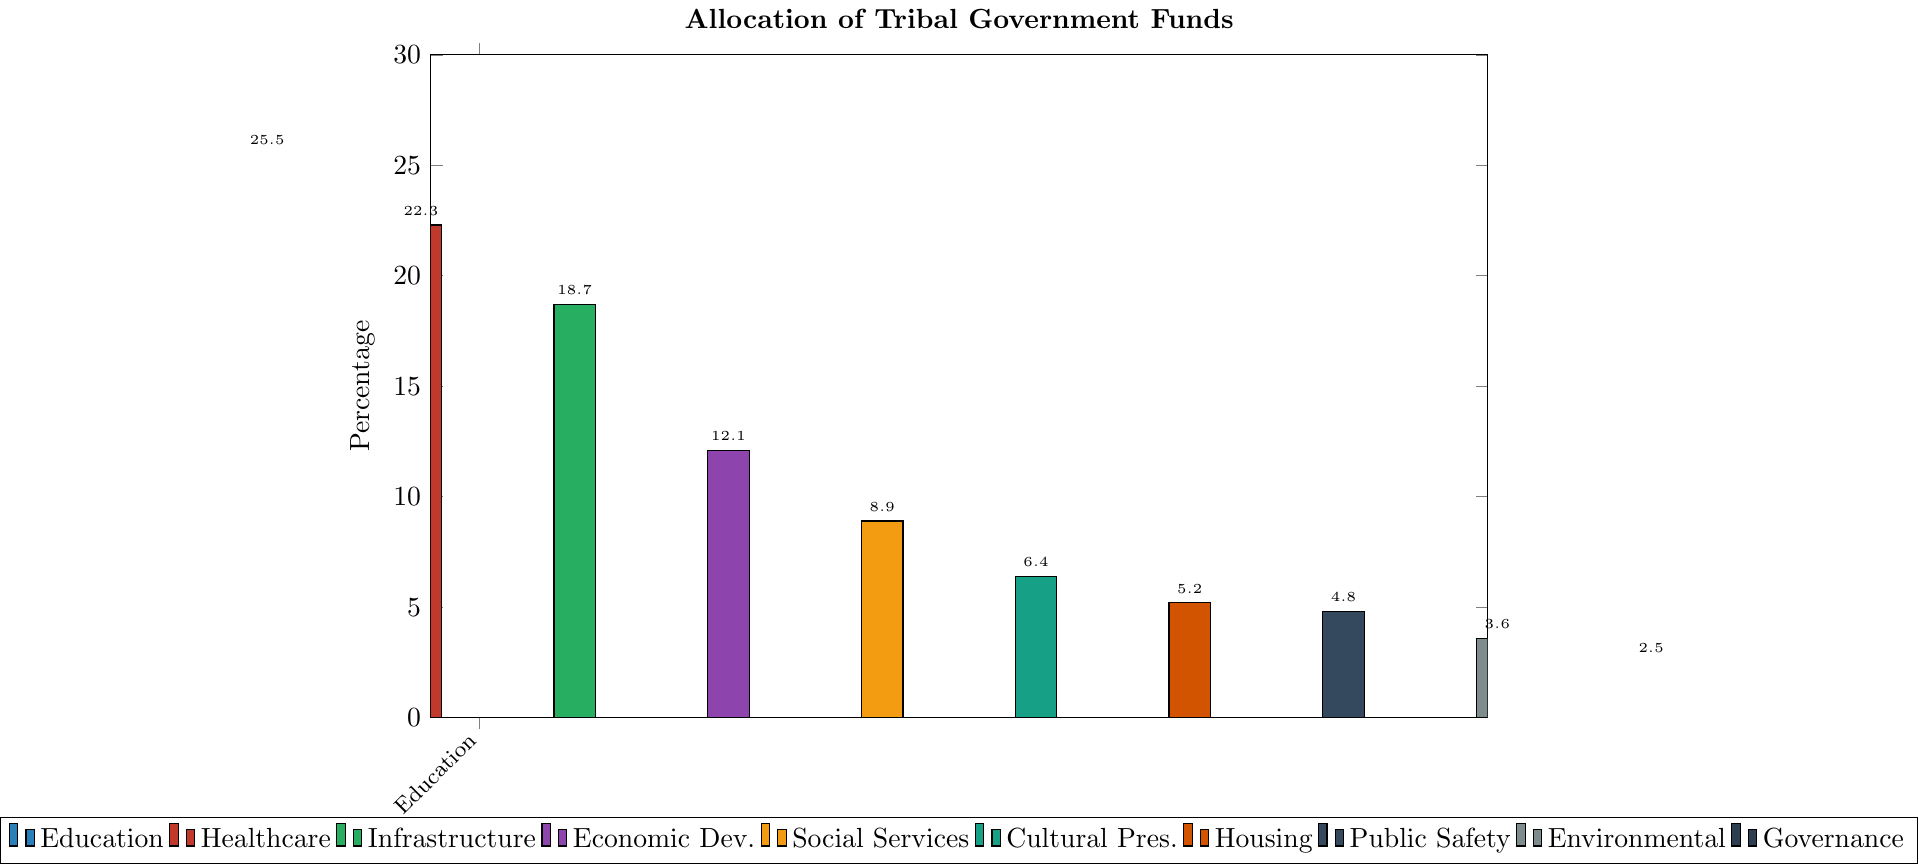Which sector receives the highest percentage of funds? The bar chart shows the allocation of tribal government funds across various sectors, with the highest bar representing the sector that receives the most funds.
Answer: Education Which two sectors received fund allocations closest to 5%? By observing the lengths of the bars for different sectors, the two sectors with percentages closest to 5% are those whose bars are of similar height around the 5% mark.
Answer: Housing and Public Safety How much more percentage of funds does education receive compared to healthcare? The percentage of funds for education is 25.5% and for healthcare is 22.3%. The difference is calculated by subtracting the percentage for healthcare from that of education. 25.5% - 22.3% = 3.2%
Answer: 3.2% Which sector has the shortest bar in the chart, representing the smallest percentage of funds? The shortest bar indicates the smallest percentage of funds allocated to a sector.
Answer: Governance and Administration What is the total percentage of funds allocated to Education, Healthcare, and Infrastructure? Sum the percentages for Education (25.5%), Healthcare (22.3%), and Infrastructure (18.7%). 25.5% + 22.3% + 18.7% = 66.5%
Answer: 66.5% Which sector's bar is blue in the chart? By observing the colors used in the bar chart, the blue bar corresponds to a specific sector.
Answer: Education How much less percentage of funds does Cultural Preservation receive compared to Economic Development? The percentage of funds for Economic Development is 12.1% and for Cultural Preservation is 6.4%. The difference is found by subtracting the percentage of Cultural Preservation from Economic Development. 12.1% - 6.4% = 5.7%
Answer: 5.7% Which sectors have a percentage of less than 10%? The sectors with bars shorter than the 10% mark represent less than 10% of the funds.
Answer: Social Services, Cultural Preservation, Housing, Public Safety, Environmental Protection, Governance and Administration Is the allocation for Infrastructure greater than the sum of Housing and Environmental Protection? Compare the percentage for Infrastructure (18.7%) with the sum of the percentages for Housing (5.2%) and Environmental Protection (3.6%). 5.2% + 3.6% = 8.8%, and 18.7% > 8.8%.
Answer: Yes What's the combined percentage of funds for Social Services, Cultural Preservation, and Housing? Sum the percentages for Social Services (8.9%), Cultural Preservation (6.4%), and Housing (5.2%). 8.9% + 6.4% + 5.2% = 20.5%
Answer: 20.5% 